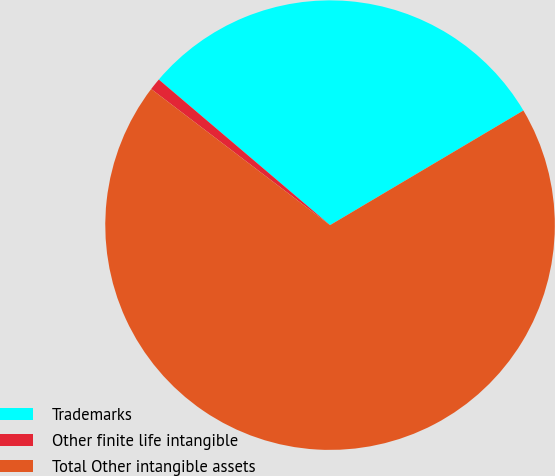<chart> <loc_0><loc_0><loc_500><loc_500><pie_chart><fcel>Trademarks<fcel>Other finite life intangible<fcel>Total Other intangible assets<nl><fcel>30.27%<fcel>0.86%<fcel>68.87%<nl></chart> 